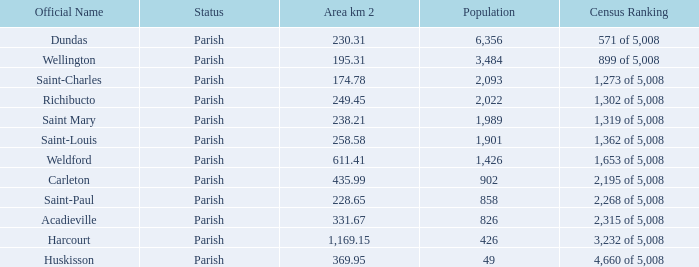For Saint-Paul parish, if it has an area of over 228.65 kilometers how many people live there? 0.0. 